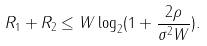Convert formula to latex. <formula><loc_0><loc_0><loc_500><loc_500>R _ { 1 } + R _ { 2 } \leq W \log _ { 2 } ( 1 + \frac { 2 \rho } { \sigma ^ { 2 } W } ) .</formula> 